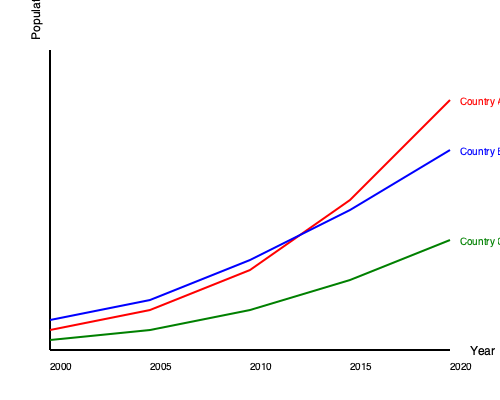Based on the line graph showing population growth rates for three Asian countries from 2000 to 2020, which country experienced the most rapid population growth during this period, and what factors might have contributed to this trend? To determine which country experienced the most rapid population growth, we need to analyze the slope of each line:

1. Country A (red line):
   - Starts at the lowest point in 2000
   - Ends at the highest point in 2020
   - The line has the steepest slope

2. Country B (blue line):
   - Starts in the middle in 2000
   - Ends in the middle in 2020
   - The line has a moderate slope

3. Country C (green line):
   - Starts at the highest point in 2000
   - Ends at the lowest point in 2020
   - The line has the gentlest slope

Country A experienced the most rapid population growth because its line has the steepest slope, indicating the fastest rate of change.

Factors that might have contributed to this trend:
1. Higher birth rates
2. Improved healthcare and lower infant mortality
3. Increased life expectancy
4. Immigration policies attracting more people
5. Economic growth leading to better living conditions

In contrast, Country C's gentle slope suggests slower growth, possibly due to:
1. Aging population
2. Lower birth rates
3. Emigration
4. Family planning policies

Country B's moderate growth could be attributed to a balance of these factors.
Answer: Country A; factors include higher birth rates, improved healthcare, increased life expectancy, immigration, and economic growth. 